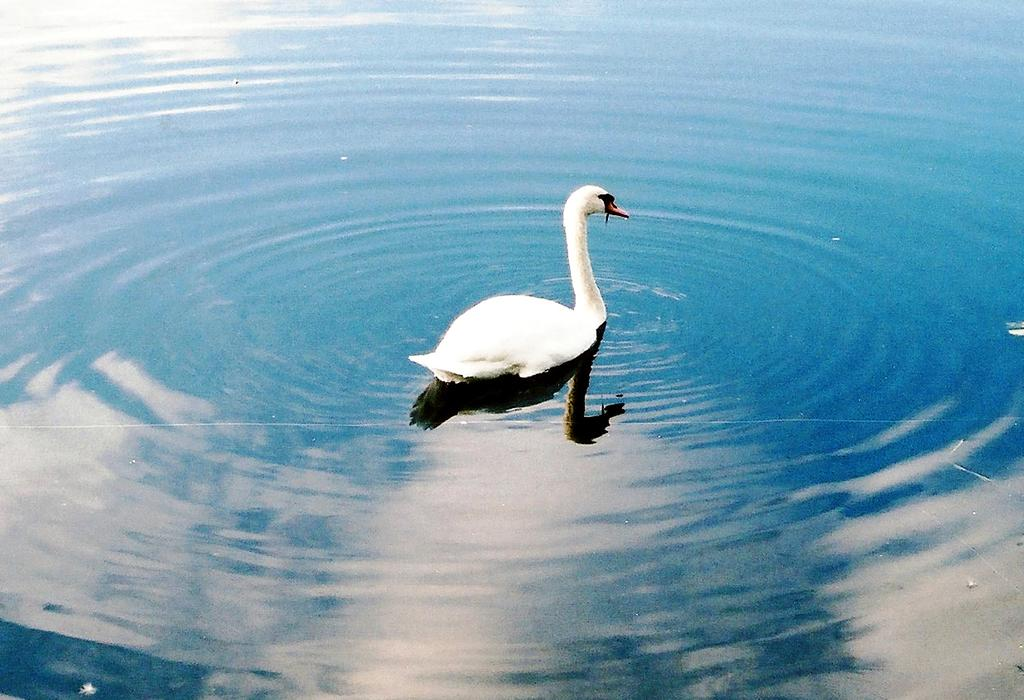What animal is present in the image? There is a swan in the image. Where is the swan located? The swan is on the water. What type of machine can be seen operating on the sidewalk in the image? There is no machine or sidewalk present in the image; it features a swan on the water. What decision does the swan make in the image? The image does not depict the swan making any decisions, as it is a still image. 